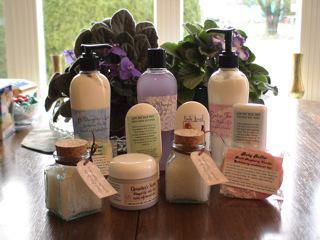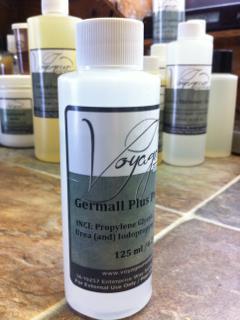The first image is the image on the left, the second image is the image on the right. Assess this claim about the two images: "Some items are on store shelves.". Correct or not? Answer yes or no. No. 